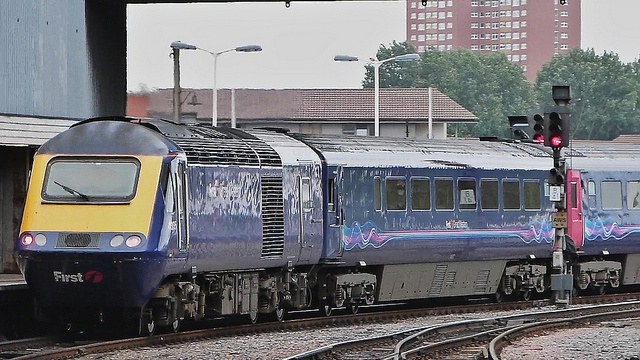Describe the objects in this image and their specific colors. I can see train in gray, black, and darkgray tones, traffic light in gray, black, and maroon tones, and traffic light in gray, black, brown, and maroon tones in this image. 